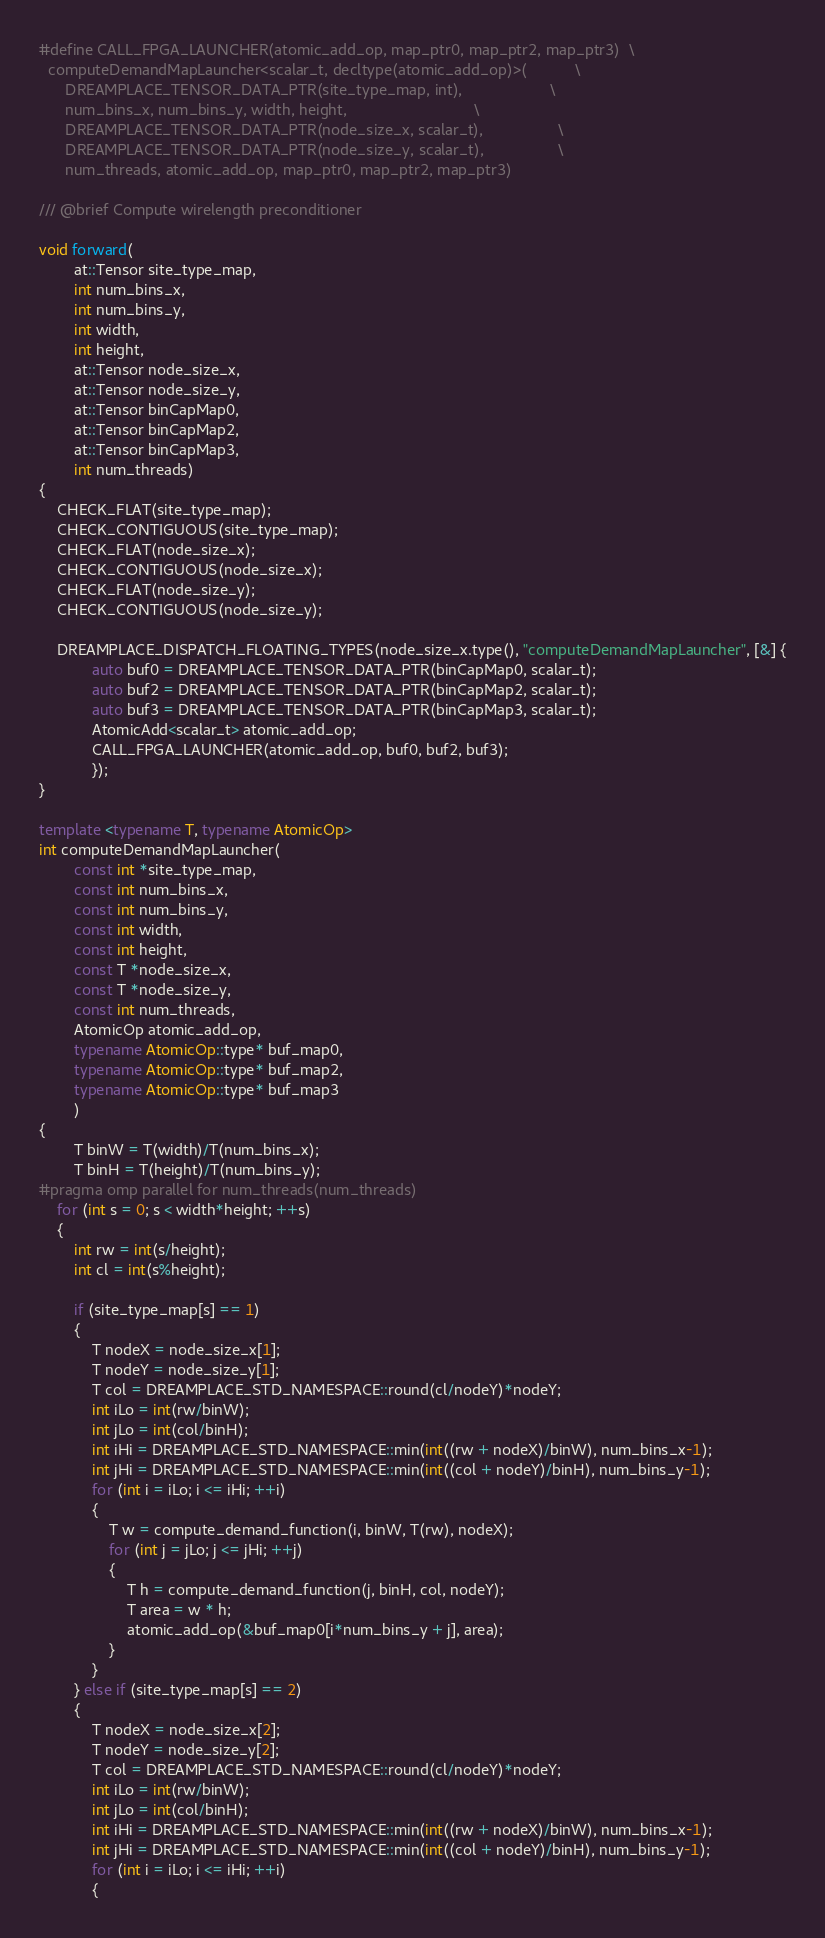<code> <loc_0><loc_0><loc_500><loc_500><_C++_>#define CALL_FPGA_LAUNCHER(atomic_add_op, map_ptr0, map_ptr2, map_ptr3)  \
  computeDemandMapLauncher<scalar_t, decltype(atomic_add_op)>(           \
      DREAMPLACE_TENSOR_DATA_PTR(site_type_map, int),                    \
      num_bins_x, num_bins_y, width, height,                             \
      DREAMPLACE_TENSOR_DATA_PTR(node_size_x, scalar_t),                 \
      DREAMPLACE_TENSOR_DATA_PTR(node_size_y, scalar_t),                 \
      num_threads, atomic_add_op, map_ptr0, map_ptr2, map_ptr3)

/// @brief Compute wirelength preconditioner

void forward(
        at::Tensor site_type_map,
        int num_bins_x,
        int num_bins_y,
        int width,
        int height,
        at::Tensor node_size_x,
        at::Tensor node_size_y,
        at::Tensor binCapMap0,
        at::Tensor binCapMap2,
        at::Tensor binCapMap3,
        int num_threads)
{
    CHECK_FLAT(site_type_map); 
    CHECK_CONTIGUOUS(site_type_map);
    CHECK_FLAT(node_size_x);
    CHECK_CONTIGUOUS(node_size_x);
    CHECK_FLAT(node_size_y);
    CHECK_CONTIGUOUS(node_size_y);

    DREAMPLACE_DISPATCH_FLOATING_TYPES(node_size_x.type(), "computeDemandMapLauncher", [&] {
            auto buf0 = DREAMPLACE_TENSOR_DATA_PTR(binCapMap0, scalar_t);
            auto buf2 = DREAMPLACE_TENSOR_DATA_PTR(binCapMap2, scalar_t);
            auto buf3 = DREAMPLACE_TENSOR_DATA_PTR(binCapMap3, scalar_t);
            AtomicAdd<scalar_t> atomic_add_op;
            CALL_FPGA_LAUNCHER(atomic_add_op, buf0, buf2, buf3);
            });
}

template <typename T, typename AtomicOp>
int computeDemandMapLauncher(
        const int *site_type_map, 
        const int num_bins_x, 
        const int num_bins_y, 
        const int width, 
        const int height, 
        const T *node_size_x, 
        const T *node_size_y, 
        const int num_threads,
        AtomicOp atomic_add_op,
        typename AtomicOp::type* buf_map0,
        typename AtomicOp::type* buf_map2,
        typename AtomicOp::type* buf_map3
        )
{
        T binW = T(width)/T(num_bins_x);
        T binH = T(height)/T(num_bins_y);
#pragma omp parallel for num_threads(num_threads)
    for (int s = 0; s < width*height; ++s)
    {
        int rw = int(s/height);
        int cl = int(s%height);

        if (site_type_map[s] == 1)
        {
            T nodeX = node_size_x[1];
            T nodeY = node_size_y[1];
            T col = DREAMPLACE_STD_NAMESPACE::round(cl/nodeY)*nodeY;
            int iLo = int(rw/binW);
            int jLo = int(col/binH);
            int iHi = DREAMPLACE_STD_NAMESPACE::min(int((rw + nodeX)/binW), num_bins_x-1);
            int jHi = DREAMPLACE_STD_NAMESPACE::min(int((col + nodeY)/binH), num_bins_y-1);
            for (int i = iLo; i <= iHi; ++i)
            {
                T w = compute_demand_function(i, binW, T(rw), nodeX);
                for (int j = jLo; j <= jHi; ++j)
                {
                    T h = compute_demand_function(j, binH, col, nodeY);
                    T area = w * h;
                    atomic_add_op(&buf_map0[i*num_bins_y + j], area);
                }
            }
        } else if (site_type_map[s] == 2)
        {
            T nodeX = node_size_x[2];
            T nodeY = node_size_y[2];
            T col = DREAMPLACE_STD_NAMESPACE::round(cl/nodeY)*nodeY;
            int iLo = int(rw/binW);
            int jLo = int(col/binH);
            int iHi = DREAMPLACE_STD_NAMESPACE::min(int((rw + nodeX)/binW), num_bins_x-1);
            int jHi = DREAMPLACE_STD_NAMESPACE::min(int((col + nodeY)/binH), num_bins_y-1);
            for (int i = iLo; i <= iHi; ++i)
            {</code> 